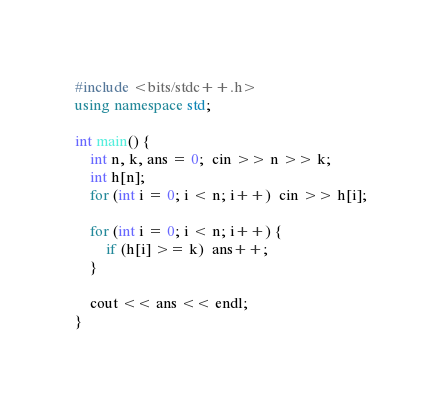<code> <loc_0><loc_0><loc_500><loc_500><_C++_>#include <bits/stdc++.h>
using namespace std;
 
int main() {
    int n, k, ans = 0;  cin >> n >> k;
    int h[n];
    for (int i = 0; i < n; i++)  cin >> h[i];
 
    for (int i = 0; i < n; i++) {
        if (h[i] >= k)  ans++;
    }
 
    cout << ans << endl;
}</code> 